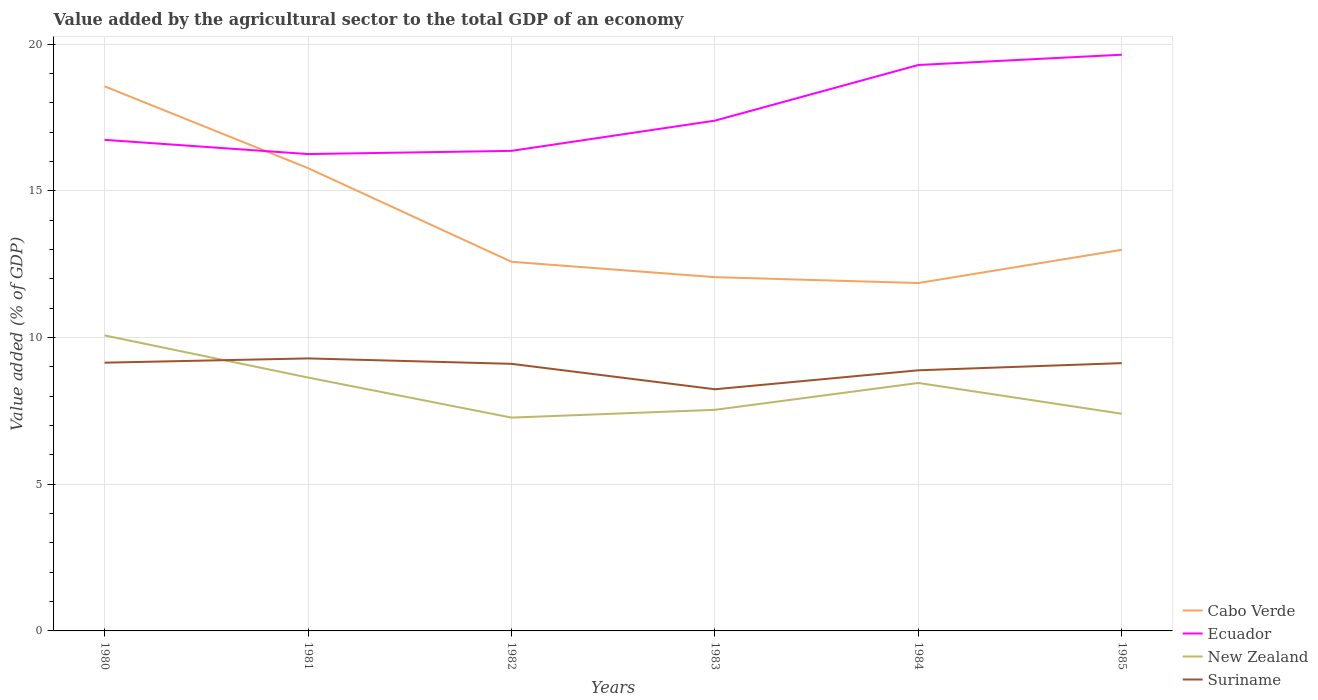Is the number of lines equal to the number of legend labels?
Offer a terse response. Yes. Across all years, what is the maximum value added by the agricultural sector to the total GDP in Cabo Verde?
Your answer should be very brief. 11.86. In which year was the value added by the agricultural sector to the total GDP in Cabo Verde maximum?
Offer a very short reply. 1984. What is the total value added by the agricultural sector to the total GDP in Cabo Verde in the graph?
Ensure brevity in your answer.  3.72. What is the difference between the highest and the second highest value added by the agricultural sector to the total GDP in New Zealand?
Offer a very short reply. 2.8. Are the values on the major ticks of Y-axis written in scientific E-notation?
Provide a short and direct response. No. How are the legend labels stacked?
Provide a succinct answer. Vertical. What is the title of the graph?
Offer a terse response. Value added by the agricultural sector to the total GDP of an economy. What is the label or title of the X-axis?
Offer a terse response. Years. What is the label or title of the Y-axis?
Your answer should be very brief. Value added (% of GDP). What is the Value added (% of GDP) in Cabo Verde in 1980?
Give a very brief answer. 18.56. What is the Value added (% of GDP) of Ecuador in 1980?
Your response must be concise. 16.74. What is the Value added (% of GDP) of New Zealand in 1980?
Make the answer very short. 10.07. What is the Value added (% of GDP) in Suriname in 1980?
Give a very brief answer. 9.14. What is the Value added (% of GDP) in Cabo Verde in 1981?
Give a very brief answer. 15.77. What is the Value added (% of GDP) of Ecuador in 1981?
Provide a succinct answer. 16.25. What is the Value added (% of GDP) of New Zealand in 1981?
Offer a terse response. 8.64. What is the Value added (% of GDP) of Suriname in 1981?
Provide a succinct answer. 9.29. What is the Value added (% of GDP) of Cabo Verde in 1982?
Offer a very short reply. 12.58. What is the Value added (% of GDP) of Ecuador in 1982?
Provide a succinct answer. 16.36. What is the Value added (% of GDP) in New Zealand in 1982?
Your answer should be compact. 7.27. What is the Value added (% of GDP) of Suriname in 1982?
Ensure brevity in your answer.  9.1. What is the Value added (% of GDP) of Cabo Verde in 1983?
Give a very brief answer. 12.06. What is the Value added (% of GDP) in Ecuador in 1983?
Give a very brief answer. 17.39. What is the Value added (% of GDP) of New Zealand in 1983?
Make the answer very short. 7.54. What is the Value added (% of GDP) of Suriname in 1983?
Your response must be concise. 8.24. What is the Value added (% of GDP) in Cabo Verde in 1984?
Your answer should be compact. 11.86. What is the Value added (% of GDP) of Ecuador in 1984?
Keep it short and to the point. 19.29. What is the Value added (% of GDP) of New Zealand in 1984?
Offer a terse response. 8.45. What is the Value added (% of GDP) of Suriname in 1984?
Offer a terse response. 8.88. What is the Value added (% of GDP) of Cabo Verde in 1985?
Make the answer very short. 12.99. What is the Value added (% of GDP) in Ecuador in 1985?
Offer a terse response. 19.64. What is the Value added (% of GDP) of New Zealand in 1985?
Your answer should be compact. 7.4. What is the Value added (% of GDP) in Suriname in 1985?
Your answer should be compact. 9.13. Across all years, what is the maximum Value added (% of GDP) in Cabo Verde?
Give a very brief answer. 18.56. Across all years, what is the maximum Value added (% of GDP) of Ecuador?
Keep it short and to the point. 19.64. Across all years, what is the maximum Value added (% of GDP) in New Zealand?
Your answer should be compact. 10.07. Across all years, what is the maximum Value added (% of GDP) of Suriname?
Provide a short and direct response. 9.29. Across all years, what is the minimum Value added (% of GDP) of Cabo Verde?
Ensure brevity in your answer.  11.86. Across all years, what is the minimum Value added (% of GDP) in Ecuador?
Offer a terse response. 16.25. Across all years, what is the minimum Value added (% of GDP) in New Zealand?
Provide a succinct answer. 7.27. Across all years, what is the minimum Value added (% of GDP) in Suriname?
Ensure brevity in your answer.  8.24. What is the total Value added (% of GDP) in Cabo Verde in the graph?
Offer a terse response. 83.82. What is the total Value added (% of GDP) in Ecuador in the graph?
Your answer should be compact. 105.67. What is the total Value added (% of GDP) in New Zealand in the graph?
Keep it short and to the point. 49.36. What is the total Value added (% of GDP) of Suriname in the graph?
Provide a succinct answer. 53.78. What is the difference between the Value added (% of GDP) of Cabo Verde in 1980 and that in 1981?
Offer a very short reply. 2.79. What is the difference between the Value added (% of GDP) of Ecuador in 1980 and that in 1981?
Offer a terse response. 0.48. What is the difference between the Value added (% of GDP) of New Zealand in 1980 and that in 1981?
Ensure brevity in your answer.  1.44. What is the difference between the Value added (% of GDP) in Suriname in 1980 and that in 1981?
Your answer should be compact. -0.14. What is the difference between the Value added (% of GDP) in Cabo Verde in 1980 and that in 1982?
Keep it short and to the point. 5.98. What is the difference between the Value added (% of GDP) of Ecuador in 1980 and that in 1982?
Provide a short and direct response. 0.38. What is the difference between the Value added (% of GDP) in New Zealand in 1980 and that in 1982?
Provide a succinct answer. 2.8. What is the difference between the Value added (% of GDP) of Suriname in 1980 and that in 1982?
Your answer should be very brief. 0.04. What is the difference between the Value added (% of GDP) of Cabo Verde in 1980 and that in 1983?
Your answer should be compact. 6.5. What is the difference between the Value added (% of GDP) of Ecuador in 1980 and that in 1983?
Offer a terse response. -0.65. What is the difference between the Value added (% of GDP) of New Zealand in 1980 and that in 1983?
Make the answer very short. 2.54. What is the difference between the Value added (% of GDP) of Suriname in 1980 and that in 1983?
Provide a short and direct response. 0.91. What is the difference between the Value added (% of GDP) of Cabo Verde in 1980 and that in 1984?
Your answer should be compact. 6.7. What is the difference between the Value added (% of GDP) of Ecuador in 1980 and that in 1984?
Offer a very short reply. -2.55. What is the difference between the Value added (% of GDP) of New Zealand in 1980 and that in 1984?
Your answer should be very brief. 1.62. What is the difference between the Value added (% of GDP) in Suriname in 1980 and that in 1984?
Make the answer very short. 0.26. What is the difference between the Value added (% of GDP) in Cabo Verde in 1980 and that in 1985?
Provide a short and direct response. 5.57. What is the difference between the Value added (% of GDP) of Ecuador in 1980 and that in 1985?
Make the answer very short. -2.9. What is the difference between the Value added (% of GDP) of New Zealand in 1980 and that in 1985?
Provide a short and direct response. 2.67. What is the difference between the Value added (% of GDP) in Suriname in 1980 and that in 1985?
Offer a very short reply. 0.02. What is the difference between the Value added (% of GDP) in Cabo Verde in 1981 and that in 1982?
Give a very brief answer. 3.19. What is the difference between the Value added (% of GDP) in Ecuador in 1981 and that in 1982?
Your answer should be very brief. -0.11. What is the difference between the Value added (% of GDP) of New Zealand in 1981 and that in 1982?
Offer a very short reply. 1.37. What is the difference between the Value added (% of GDP) of Suriname in 1981 and that in 1982?
Offer a terse response. 0.18. What is the difference between the Value added (% of GDP) of Cabo Verde in 1981 and that in 1983?
Make the answer very short. 3.72. What is the difference between the Value added (% of GDP) of Ecuador in 1981 and that in 1983?
Give a very brief answer. -1.14. What is the difference between the Value added (% of GDP) in New Zealand in 1981 and that in 1983?
Provide a succinct answer. 1.1. What is the difference between the Value added (% of GDP) of Suriname in 1981 and that in 1983?
Give a very brief answer. 1.05. What is the difference between the Value added (% of GDP) of Cabo Verde in 1981 and that in 1984?
Your answer should be compact. 3.92. What is the difference between the Value added (% of GDP) of Ecuador in 1981 and that in 1984?
Keep it short and to the point. -3.04. What is the difference between the Value added (% of GDP) in New Zealand in 1981 and that in 1984?
Provide a short and direct response. 0.18. What is the difference between the Value added (% of GDP) of Suriname in 1981 and that in 1984?
Keep it short and to the point. 0.4. What is the difference between the Value added (% of GDP) in Cabo Verde in 1981 and that in 1985?
Your answer should be compact. 2.78. What is the difference between the Value added (% of GDP) in Ecuador in 1981 and that in 1985?
Provide a short and direct response. -3.39. What is the difference between the Value added (% of GDP) in New Zealand in 1981 and that in 1985?
Your answer should be very brief. 1.23. What is the difference between the Value added (% of GDP) in Suriname in 1981 and that in 1985?
Offer a terse response. 0.16. What is the difference between the Value added (% of GDP) of Cabo Verde in 1982 and that in 1983?
Your response must be concise. 0.52. What is the difference between the Value added (% of GDP) in Ecuador in 1982 and that in 1983?
Offer a terse response. -1.03. What is the difference between the Value added (% of GDP) in New Zealand in 1982 and that in 1983?
Your answer should be compact. -0.27. What is the difference between the Value added (% of GDP) in Suriname in 1982 and that in 1983?
Make the answer very short. 0.87. What is the difference between the Value added (% of GDP) in Cabo Verde in 1982 and that in 1984?
Keep it short and to the point. 0.72. What is the difference between the Value added (% of GDP) in Ecuador in 1982 and that in 1984?
Keep it short and to the point. -2.93. What is the difference between the Value added (% of GDP) of New Zealand in 1982 and that in 1984?
Keep it short and to the point. -1.18. What is the difference between the Value added (% of GDP) in Suriname in 1982 and that in 1984?
Your answer should be compact. 0.22. What is the difference between the Value added (% of GDP) in Cabo Verde in 1982 and that in 1985?
Provide a succinct answer. -0.41. What is the difference between the Value added (% of GDP) in Ecuador in 1982 and that in 1985?
Give a very brief answer. -3.28. What is the difference between the Value added (% of GDP) in New Zealand in 1982 and that in 1985?
Provide a succinct answer. -0.13. What is the difference between the Value added (% of GDP) in Suriname in 1982 and that in 1985?
Ensure brevity in your answer.  -0.02. What is the difference between the Value added (% of GDP) in Cabo Verde in 1983 and that in 1984?
Offer a terse response. 0.2. What is the difference between the Value added (% of GDP) of Ecuador in 1983 and that in 1984?
Provide a short and direct response. -1.9. What is the difference between the Value added (% of GDP) of New Zealand in 1983 and that in 1984?
Your answer should be compact. -0.92. What is the difference between the Value added (% of GDP) in Suriname in 1983 and that in 1984?
Give a very brief answer. -0.65. What is the difference between the Value added (% of GDP) in Cabo Verde in 1983 and that in 1985?
Keep it short and to the point. -0.93. What is the difference between the Value added (% of GDP) in Ecuador in 1983 and that in 1985?
Offer a very short reply. -2.25. What is the difference between the Value added (% of GDP) in New Zealand in 1983 and that in 1985?
Offer a very short reply. 0.13. What is the difference between the Value added (% of GDP) of Suriname in 1983 and that in 1985?
Provide a succinct answer. -0.89. What is the difference between the Value added (% of GDP) in Cabo Verde in 1984 and that in 1985?
Ensure brevity in your answer.  -1.13. What is the difference between the Value added (% of GDP) in Ecuador in 1984 and that in 1985?
Give a very brief answer. -0.35. What is the difference between the Value added (% of GDP) in New Zealand in 1984 and that in 1985?
Your answer should be compact. 1.05. What is the difference between the Value added (% of GDP) in Suriname in 1984 and that in 1985?
Keep it short and to the point. -0.24. What is the difference between the Value added (% of GDP) of Cabo Verde in 1980 and the Value added (% of GDP) of Ecuador in 1981?
Keep it short and to the point. 2.31. What is the difference between the Value added (% of GDP) of Cabo Verde in 1980 and the Value added (% of GDP) of New Zealand in 1981?
Ensure brevity in your answer.  9.92. What is the difference between the Value added (% of GDP) in Cabo Verde in 1980 and the Value added (% of GDP) in Suriname in 1981?
Make the answer very short. 9.27. What is the difference between the Value added (% of GDP) in Ecuador in 1980 and the Value added (% of GDP) in New Zealand in 1981?
Your answer should be very brief. 8.1. What is the difference between the Value added (% of GDP) in Ecuador in 1980 and the Value added (% of GDP) in Suriname in 1981?
Ensure brevity in your answer.  7.45. What is the difference between the Value added (% of GDP) of New Zealand in 1980 and the Value added (% of GDP) of Suriname in 1981?
Provide a succinct answer. 0.78. What is the difference between the Value added (% of GDP) of Cabo Verde in 1980 and the Value added (% of GDP) of Ecuador in 1982?
Your answer should be compact. 2.2. What is the difference between the Value added (% of GDP) of Cabo Verde in 1980 and the Value added (% of GDP) of New Zealand in 1982?
Provide a succinct answer. 11.29. What is the difference between the Value added (% of GDP) of Cabo Verde in 1980 and the Value added (% of GDP) of Suriname in 1982?
Your answer should be very brief. 9.46. What is the difference between the Value added (% of GDP) in Ecuador in 1980 and the Value added (% of GDP) in New Zealand in 1982?
Keep it short and to the point. 9.47. What is the difference between the Value added (% of GDP) of Ecuador in 1980 and the Value added (% of GDP) of Suriname in 1982?
Offer a very short reply. 7.63. What is the difference between the Value added (% of GDP) of New Zealand in 1980 and the Value added (% of GDP) of Suriname in 1982?
Ensure brevity in your answer.  0.97. What is the difference between the Value added (% of GDP) of Cabo Verde in 1980 and the Value added (% of GDP) of Ecuador in 1983?
Give a very brief answer. 1.17. What is the difference between the Value added (% of GDP) of Cabo Verde in 1980 and the Value added (% of GDP) of New Zealand in 1983?
Your answer should be very brief. 11.02. What is the difference between the Value added (% of GDP) in Cabo Verde in 1980 and the Value added (% of GDP) in Suriname in 1983?
Offer a terse response. 10.32. What is the difference between the Value added (% of GDP) in Ecuador in 1980 and the Value added (% of GDP) in New Zealand in 1983?
Give a very brief answer. 9.2. What is the difference between the Value added (% of GDP) of Ecuador in 1980 and the Value added (% of GDP) of Suriname in 1983?
Your answer should be compact. 8.5. What is the difference between the Value added (% of GDP) in New Zealand in 1980 and the Value added (% of GDP) in Suriname in 1983?
Ensure brevity in your answer.  1.84. What is the difference between the Value added (% of GDP) of Cabo Verde in 1980 and the Value added (% of GDP) of Ecuador in 1984?
Provide a succinct answer. -0.73. What is the difference between the Value added (% of GDP) in Cabo Verde in 1980 and the Value added (% of GDP) in New Zealand in 1984?
Make the answer very short. 10.11. What is the difference between the Value added (% of GDP) in Cabo Verde in 1980 and the Value added (% of GDP) in Suriname in 1984?
Ensure brevity in your answer.  9.68. What is the difference between the Value added (% of GDP) in Ecuador in 1980 and the Value added (% of GDP) in New Zealand in 1984?
Provide a short and direct response. 8.29. What is the difference between the Value added (% of GDP) of Ecuador in 1980 and the Value added (% of GDP) of Suriname in 1984?
Provide a succinct answer. 7.85. What is the difference between the Value added (% of GDP) in New Zealand in 1980 and the Value added (% of GDP) in Suriname in 1984?
Offer a terse response. 1.19. What is the difference between the Value added (% of GDP) in Cabo Verde in 1980 and the Value added (% of GDP) in Ecuador in 1985?
Your answer should be compact. -1.08. What is the difference between the Value added (% of GDP) of Cabo Verde in 1980 and the Value added (% of GDP) of New Zealand in 1985?
Provide a succinct answer. 11.16. What is the difference between the Value added (% of GDP) in Cabo Verde in 1980 and the Value added (% of GDP) in Suriname in 1985?
Your answer should be compact. 9.43. What is the difference between the Value added (% of GDP) in Ecuador in 1980 and the Value added (% of GDP) in New Zealand in 1985?
Give a very brief answer. 9.34. What is the difference between the Value added (% of GDP) of Ecuador in 1980 and the Value added (% of GDP) of Suriname in 1985?
Your answer should be compact. 7.61. What is the difference between the Value added (% of GDP) in New Zealand in 1980 and the Value added (% of GDP) in Suriname in 1985?
Give a very brief answer. 0.94. What is the difference between the Value added (% of GDP) in Cabo Verde in 1981 and the Value added (% of GDP) in Ecuador in 1982?
Provide a short and direct response. -0.59. What is the difference between the Value added (% of GDP) of Cabo Verde in 1981 and the Value added (% of GDP) of New Zealand in 1982?
Ensure brevity in your answer.  8.5. What is the difference between the Value added (% of GDP) in Cabo Verde in 1981 and the Value added (% of GDP) in Suriname in 1982?
Provide a succinct answer. 6.67. What is the difference between the Value added (% of GDP) in Ecuador in 1981 and the Value added (% of GDP) in New Zealand in 1982?
Provide a succinct answer. 8.98. What is the difference between the Value added (% of GDP) of Ecuador in 1981 and the Value added (% of GDP) of Suriname in 1982?
Make the answer very short. 7.15. What is the difference between the Value added (% of GDP) of New Zealand in 1981 and the Value added (% of GDP) of Suriname in 1982?
Keep it short and to the point. -0.47. What is the difference between the Value added (% of GDP) of Cabo Verde in 1981 and the Value added (% of GDP) of Ecuador in 1983?
Offer a very short reply. -1.62. What is the difference between the Value added (% of GDP) of Cabo Verde in 1981 and the Value added (% of GDP) of New Zealand in 1983?
Provide a succinct answer. 8.24. What is the difference between the Value added (% of GDP) of Cabo Verde in 1981 and the Value added (% of GDP) of Suriname in 1983?
Keep it short and to the point. 7.54. What is the difference between the Value added (% of GDP) of Ecuador in 1981 and the Value added (% of GDP) of New Zealand in 1983?
Ensure brevity in your answer.  8.72. What is the difference between the Value added (% of GDP) in Ecuador in 1981 and the Value added (% of GDP) in Suriname in 1983?
Keep it short and to the point. 8.02. What is the difference between the Value added (% of GDP) of New Zealand in 1981 and the Value added (% of GDP) of Suriname in 1983?
Provide a short and direct response. 0.4. What is the difference between the Value added (% of GDP) in Cabo Verde in 1981 and the Value added (% of GDP) in Ecuador in 1984?
Make the answer very short. -3.51. What is the difference between the Value added (% of GDP) of Cabo Verde in 1981 and the Value added (% of GDP) of New Zealand in 1984?
Your answer should be very brief. 7.32. What is the difference between the Value added (% of GDP) in Cabo Verde in 1981 and the Value added (% of GDP) in Suriname in 1984?
Your answer should be compact. 6.89. What is the difference between the Value added (% of GDP) of Ecuador in 1981 and the Value added (% of GDP) of New Zealand in 1984?
Offer a very short reply. 7.8. What is the difference between the Value added (% of GDP) in Ecuador in 1981 and the Value added (% of GDP) in Suriname in 1984?
Make the answer very short. 7.37. What is the difference between the Value added (% of GDP) in New Zealand in 1981 and the Value added (% of GDP) in Suriname in 1984?
Offer a terse response. -0.25. What is the difference between the Value added (% of GDP) in Cabo Verde in 1981 and the Value added (% of GDP) in Ecuador in 1985?
Keep it short and to the point. -3.87. What is the difference between the Value added (% of GDP) in Cabo Verde in 1981 and the Value added (% of GDP) in New Zealand in 1985?
Offer a very short reply. 8.37. What is the difference between the Value added (% of GDP) in Cabo Verde in 1981 and the Value added (% of GDP) in Suriname in 1985?
Ensure brevity in your answer.  6.65. What is the difference between the Value added (% of GDP) in Ecuador in 1981 and the Value added (% of GDP) in New Zealand in 1985?
Offer a terse response. 8.85. What is the difference between the Value added (% of GDP) in Ecuador in 1981 and the Value added (% of GDP) in Suriname in 1985?
Keep it short and to the point. 7.13. What is the difference between the Value added (% of GDP) of New Zealand in 1981 and the Value added (% of GDP) of Suriname in 1985?
Your answer should be compact. -0.49. What is the difference between the Value added (% of GDP) of Cabo Verde in 1982 and the Value added (% of GDP) of Ecuador in 1983?
Keep it short and to the point. -4.81. What is the difference between the Value added (% of GDP) in Cabo Verde in 1982 and the Value added (% of GDP) in New Zealand in 1983?
Keep it short and to the point. 5.04. What is the difference between the Value added (% of GDP) of Cabo Verde in 1982 and the Value added (% of GDP) of Suriname in 1983?
Ensure brevity in your answer.  4.34. What is the difference between the Value added (% of GDP) in Ecuador in 1982 and the Value added (% of GDP) in New Zealand in 1983?
Give a very brief answer. 8.83. What is the difference between the Value added (% of GDP) in Ecuador in 1982 and the Value added (% of GDP) in Suriname in 1983?
Offer a very short reply. 8.12. What is the difference between the Value added (% of GDP) in New Zealand in 1982 and the Value added (% of GDP) in Suriname in 1983?
Give a very brief answer. -0.97. What is the difference between the Value added (% of GDP) in Cabo Verde in 1982 and the Value added (% of GDP) in Ecuador in 1984?
Give a very brief answer. -6.71. What is the difference between the Value added (% of GDP) of Cabo Verde in 1982 and the Value added (% of GDP) of New Zealand in 1984?
Your answer should be very brief. 4.13. What is the difference between the Value added (% of GDP) of Cabo Verde in 1982 and the Value added (% of GDP) of Suriname in 1984?
Your answer should be compact. 3.7. What is the difference between the Value added (% of GDP) of Ecuador in 1982 and the Value added (% of GDP) of New Zealand in 1984?
Ensure brevity in your answer.  7.91. What is the difference between the Value added (% of GDP) in Ecuador in 1982 and the Value added (% of GDP) in Suriname in 1984?
Your answer should be very brief. 7.48. What is the difference between the Value added (% of GDP) in New Zealand in 1982 and the Value added (% of GDP) in Suriname in 1984?
Your response must be concise. -1.61. What is the difference between the Value added (% of GDP) in Cabo Verde in 1982 and the Value added (% of GDP) in Ecuador in 1985?
Your answer should be very brief. -7.06. What is the difference between the Value added (% of GDP) of Cabo Verde in 1982 and the Value added (% of GDP) of New Zealand in 1985?
Ensure brevity in your answer.  5.18. What is the difference between the Value added (% of GDP) of Cabo Verde in 1982 and the Value added (% of GDP) of Suriname in 1985?
Offer a very short reply. 3.45. What is the difference between the Value added (% of GDP) in Ecuador in 1982 and the Value added (% of GDP) in New Zealand in 1985?
Provide a succinct answer. 8.96. What is the difference between the Value added (% of GDP) in Ecuador in 1982 and the Value added (% of GDP) in Suriname in 1985?
Your answer should be compact. 7.23. What is the difference between the Value added (% of GDP) of New Zealand in 1982 and the Value added (% of GDP) of Suriname in 1985?
Provide a succinct answer. -1.86. What is the difference between the Value added (% of GDP) of Cabo Verde in 1983 and the Value added (% of GDP) of Ecuador in 1984?
Provide a succinct answer. -7.23. What is the difference between the Value added (% of GDP) of Cabo Verde in 1983 and the Value added (% of GDP) of New Zealand in 1984?
Keep it short and to the point. 3.61. What is the difference between the Value added (% of GDP) in Cabo Verde in 1983 and the Value added (% of GDP) in Suriname in 1984?
Provide a short and direct response. 3.17. What is the difference between the Value added (% of GDP) in Ecuador in 1983 and the Value added (% of GDP) in New Zealand in 1984?
Give a very brief answer. 8.94. What is the difference between the Value added (% of GDP) in Ecuador in 1983 and the Value added (% of GDP) in Suriname in 1984?
Provide a succinct answer. 8.51. What is the difference between the Value added (% of GDP) in New Zealand in 1983 and the Value added (% of GDP) in Suriname in 1984?
Offer a terse response. -1.35. What is the difference between the Value added (% of GDP) in Cabo Verde in 1983 and the Value added (% of GDP) in Ecuador in 1985?
Provide a succinct answer. -7.58. What is the difference between the Value added (% of GDP) in Cabo Verde in 1983 and the Value added (% of GDP) in New Zealand in 1985?
Your answer should be very brief. 4.66. What is the difference between the Value added (% of GDP) of Cabo Verde in 1983 and the Value added (% of GDP) of Suriname in 1985?
Offer a very short reply. 2.93. What is the difference between the Value added (% of GDP) in Ecuador in 1983 and the Value added (% of GDP) in New Zealand in 1985?
Your answer should be compact. 9.99. What is the difference between the Value added (% of GDP) in Ecuador in 1983 and the Value added (% of GDP) in Suriname in 1985?
Offer a very short reply. 8.26. What is the difference between the Value added (% of GDP) of New Zealand in 1983 and the Value added (% of GDP) of Suriname in 1985?
Offer a very short reply. -1.59. What is the difference between the Value added (% of GDP) in Cabo Verde in 1984 and the Value added (% of GDP) in Ecuador in 1985?
Offer a terse response. -7.78. What is the difference between the Value added (% of GDP) in Cabo Verde in 1984 and the Value added (% of GDP) in New Zealand in 1985?
Your answer should be compact. 4.46. What is the difference between the Value added (% of GDP) of Cabo Verde in 1984 and the Value added (% of GDP) of Suriname in 1985?
Make the answer very short. 2.73. What is the difference between the Value added (% of GDP) of Ecuador in 1984 and the Value added (% of GDP) of New Zealand in 1985?
Your answer should be very brief. 11.89. What is the difference between the Value added (% of GDP) in Ecuador in 1984 and the Value added (% of GDP) in Suriname in 1985?
Your response must be concise. 10.16. What is the difference between the Value added (% of GDP) of New Zealand in 1984 and the Value added (% of GDP) of Suriname in 1985?
Offer a terse response. -0.68. What is the average Value added (% of GDP) in Cabo Verde per year?
Offer a very short reply. 13.97. What is the average Value added (% of GDP) of Ecuador per year?
Provide a short and direct response. 17.61. What is the average Value added (% of GDP) of New Zealand per year?
Provide a succinct answer. 8.23. What is the average Value added (% of GDP) of Suriname per year?
Offer a very short reply. 8.96. In the year 1980, what is the difference between the Value added (% of GDP) in Cabo Verde and Value added (% of GDP) in Ecuador?
Make the answer very short. 1.82. In the year 1980, what is the difference between the Value added (% of GDP) of Cabo Verde and Value added (% of GDP) of New Zealand?
Make the answer very short. 8.49. In the year 1980, what is the difference between the Value added (% of GDP) of Cabo Verde and Value added (% of GDP) of Suriname?
Ensure brevity in your answer.  9.42. In the year 1980, what is the difference between the Value added (% of GDP) of Ecuador and Value added (% of GDP) of New Zealand?
Ensure brevity in your answer.  6.67. In the year 1980, what is the difference between the Value added (% of GDP) of Ecuador and Value added (% of GDP) of Suriname?
Give a very brief answer. 7.59. In the year 1980, what is the difference between the Value added (% of GDP) in New Zealand and Value added (% of GDP) in Suriname?
Keep it short and to the point. 0.93. In the year 1981, what is the difference between the Value added (% of GDP) in Cabo Verde and Value added (% of GDP) in Ecuador?
Your answer should be very brief. -0.48. In the year 1981, what is the difference between the Value added (% of GDP) in Cabo Verde and Value added (% of GDP) in New Zealand?
Provide a succinct answer. 7.14. In the year 1981, what is the difference between the Value added (% of GDP) of Cabo Verde and Value added (% of GDP) of Suriname?
Give a very brief answer. 6.49. In the year 1981, what is the difference between the Value added (% of GDP) in Ecuador and Value added (% of GDP) in New Zealand?
Ensure brevity in your answer.  7.62. In the year 1981, what is the difference between the Value added (% of GDP) in Ecuador and Value added (% of GDP) in Suriname?
Your answer should be very brief. 6.96. In the year 1981, what is the difference between the Value added (% of GDP) in New Zealand and Value added (% of GDP) in Suriname?
Make the answer very short. -0.65. In the year 1982, what is the difference between the Value added (% of GDP) of Cabo Verde and Value added (% of GDP) of Ecuador?
Your response must be concise. -3.78. In the year 1982, what is the difference between the Value added (% of GDP) of Cabo Verde and Value added (% of GDP) of New Zealand?
Give a very brief answer. 5.31. In the year 1982, what is the difference between the Value added (% of GDP) of Cabo Verde and Value added (% of GDP) of Suriname?
Provide a short and direct response. 3.48. In the year 1982, what is the difference between the Value added (% of GDP) of Ecuador and Value added (% of GDP) of New Zealand?
Keep it short and to the point. 9.09. In the year 1982, what is the difference between the Value added (% of GDP) of Ecuador and Value added (% of GDP) of Suriname?
Your answer should be compact. 7.26. In the year 1982, what is the difference between the Value added (% of GDP) in New Zealand and Value added (% of GDP) in Suriname?
Provide a succinct answer. -1.83. In the year 1983, what is the difference between the Value added (% of GDP) in Cabo Verde and Value added (% of GDP) in Ecuador?
Provide a short and direct response. -5.33. In the year 1983, what is the difference between the Value added (% of GDP) of Cabo Verde and Value added (% of GDP) of New Zealand?
Offer a terse response. 4.52. In the year 1983, what is the difference between the Value added (% of GDP) in Cabo Verde and Value added (% of GDP) in Suriname?
Provide a succinct answer. 3.82. In the year 1983, what is the difference between the Value added (% of GDP) of Ecuador and Value added (% of GDP) of New Zealand?
Offer a very short reply. 9.86. In the year 1983, what is the difference between the Value added (% of GDP) in Ecuador and Value added (% of GDP) in Suriname?
Make the answer very short. 9.15. In the year 1983, what is the difference between the Value added (% of GDP) in New Zealand and Value added (% of GDP) in Suriname?
Provide a succinct answer. -0.7. In the year 1984, what is the difference between the Value added (% of GDP) of Cabo Verde and Value added (% of GDP) of Ecuador?
Provide a succinct answer. -7.43. In the year 1984, what is the difference between the Value added (% of GDP) of Cabo Verde and Value added (% of GDP) of New Zealand?
Your answer should be very brief. 3.41. In the year 1984, what is the difference between the Value added (% of GDP) of Cabo Verde and Value added (% of GDP) of Suriname?
Provide a short and direct response. 2.97. In the year 1984, what is the difference between the Value added (% of GDP) of Ecuador and Value added (% of GDP) of New Zealand?
Offer a very short reply. 10.84. In the year 1984, what is the difference between the Value added (% of GDP) of Ecuador and Value added (% of GDP) of Suriname?
Give a very brief answer. 10.4. In the year 1984, what is the difference between the Value added (% of GDP) of New Zealand and Value added (% of GDP) of Suriname?
Offer a very short reply. -0.43. In the year 1985, what is the difference between the Value added (% of GDP) of Cabo Verde and Value added (% of GDP) of Ecuador?
Your answer should be compact. -6.65. In the year 1985, what is the difference between the Value added (% of GDP) in Cabo Verde and Value added (% of GDP) in New Zealand?
Your answer should be very brief. 5.59. In the year 1985, what is the difference between the Value added (% of GDP) of Cabo Verde and Value added (% of GDP) of Suriname?
Give a very brief answer. 3.86. In the year 1985, what is the difference between the Value added (% of GDP) of Ecuador and Value added (% of GDP) of New Zealand?
Offer a terse response. 12.24. In the year 1985, what is the difference between the Value added (% of GDP) in Ecuador and Value added (% of GDP) in Suriname?
Ensure brevity in your answer.  10.51. In the year 1985, what is the difference between the Value added (% of GDP) of New Zealand and Value added (% of GDP) of Suriname?
Keep it short and to the point. -1.73. What is the ratio of the Value added (% of GDP) in Cabo Verde in 1980 to that in 1981?
Provide a short and direct response. 1.18. What is the ratio of the Value added (% of GDP) of Ecuador in 1980 to that in 1981?
Your answer should be compact. 1.03. What is the ratio of the Value added (% of GDP) in New Zealand in 1980 to that in 1981?
Your answer should be compact. 1.17. What is the ratio of the Value added (% of GDP) of Suriname in 1980 to that in 1981?
Ensure brevity in your answer.  0.98. What is the ratio of the Value added (% of GDP) of Cabo Verde in 1980 to that in 1982?
Keep it short and to the point. 1.48. What is the ratio of the Value added (% of GDP) of New Zealand in 1980 to that in 1982?
Your response must be concise. 1.39. What is the ratio of the Value added (% of GDP) in Suriname in 1980 to that in 1982?
Your response must be concise. 1. What is the ratio of the Value added (% of GDP) of Cabo Verde in 1980 to that in 1983?
Your response must be concise. 1.54. What is the ratio of the Value added (% of GDP) in Ecuador in 1980 to that in 1983?
Offer a very short reply. 0.96. What is the ratio of the Value added (% of GDP) in New Zealand in 1980 to that in 1983?
Offer a very short reply. 1.34. What is the ratio of the Value added (% of GDP) in Suriname in 1980 to that in 1983?
Offer a very short reply. 1.11. What is the ratio of the Value added (% of GDP) in Cabo Verde in 1980 to that in 1984?
Offer a terse response. 1.57. What is the ratio of the Value added (% of GDP) of Ecuador in 1980 to that in 1984?
Offer a terse response. 0.87. What is the ratio of the Value added (% of GDP) of New Zealand in 1980 to that in 1984?
Provide a succinct answer. 1.19. What is the ratio of the Value added (% of GDP) in Suriname in 1980 to that in 1984?
Your answer should be very brief. 1.03. What is the ratio of the Value added (% of GDP) of Cabo Verde in 1980 to that in 1985?
Offer a very short reply. 1.43. What is the ratio of the Value added (% of GDP) in Ecuador in 1980 to that in 1985?
Your response must be concise. 0.85. What is the ratio of the Value added (% of GDP) of New Zealand in 1980 to that in 1985?
Offer a terse response. 1.36. What is the ratio of the Value added (% of GDP) of Cabo Verde in 1981 to that in 1982?
Your answer should be compact. 1.25. What is the ratio of the Value added (% of GDP) in Ecuador in 1981 to that in 1982?
Give a very brief answer. 0.99. What is the ratio of the Value added (% of GDP) of New Zealand in 1981 to that in 1982?
Offer a terse response. 1.19. What is the ratio of the Value added (% of GDP) in Suriname in 1981 to that in 1982?
Provide a succinct answer. 1.02. What is the ratio of the Value added (% of GDP) of Cabo Verde in 1981 to that in 1983?
Make the answer very short. 1.31. What is the ratio of the Value added (% of GDP) of Ecuador in 1981 to that in 1983?
Ensure brevity in your answer.  0.93. What is the ratio of the Value added (% of GDP) in New Zealand in 1981 to that in 1983?
Keep it short and to the point. 1.15. What is the ratio of the Value added (% of GDP) of Suriname in 1981 to that in 1983?
Ensure brevity in your answer.  1.13. What is the ratio of the Value added (% of GDP) of Cabo Verde in 1981 to that in 1984?
Ensure brevity in your answer.  1.33. What is the ratio of the Value added (% of GDP) of Ecuador in 1981 to that in 1984?
Make the answer very short. 0.84. What is the ratio of the Value added (% of GDP) in New Zealand in 1981 to that in 1984?
Provide a short and direct response. 1.02. What is the ratio of the Value added (% of GDP) in Suriname in 1981 to that in 1984?
Provide a succinct answer. 1.05. What is the ratio of the Value added (% of GDP) in Cabo Verde in 1981 to that in 1985?
Your answer should be compact. 1.21. What is the ratio of the Value added (% of GDP) in Ecuador in 1981 to that in 1985?
Your answer should be compact. 0.83. What is the ratio of the Value added (% of GDP) of New Zealand in 1981 to that in 1985?
Your answer should be compact. 1.17. What is the ratio of the Value added (% of GDP) in Suriname in 1981 to that in 1985?
Give a very brief answer. 1.02. What is the ratio of the Value added (% of GDP) in Cabo Verde in 1982 to that in 1983?
Your answer should be compact. 1.04. What is the ratio of the Value added (% of GDP) of Ecuador in 1982 to that in 1983?
Ensure brevity in your answer.  0.94. What is the ratio of the Value added (% of GDP) of New Zealand in 1982 to that in 1983?
Your answer should be compact. 0.96. What is the ratio of the Value added (% of GDP) in Suriname in 1982 to that in 1983?
Ensure brevity in your answer.  1.11. What is the ratio of the Value added (% of GDP) of Cabo Verde in 1982 to that in 1984?
Provide a succinct answer. 1.06. What is the ratio of the Value added (% of GDP) in Ecuador in 1982 to that in 1984?
Offer a very short reply. 0.85. What is the ratio of the Value added (% of GDP) of New Zealand in 1982 to that in 1984?
Provide a succinct answer. 0.86. What is the ratio of the Value added (% of GDP) in Suriname in 1982 to that in 1984?
Keep it short and to the point. 1.02. What is the ratio of the Value added (% of GDP) of Cabo Verde in 1982 to that in 1985?
Give a very brief answer. 0.97. What is the ratio of the Value added (% of GDP) in Ecuador in 1982 to that in 1985?
Your response must be concise. 0.83. What is the ratio of the Value added (% of GDP) in New Zealand in 1982 to that in 1985?
Keep it short and to the point. 0.98. What is the ratio of the Value added (% of GDP) in Suriname in 1982 to that in 1985?
Offer a very short reply. 1. What is the ratio of the Value added (% of GDP) of Cabo Verde in 1983 to that in 1984?
Your answer should be compact. 1.02. What is the ratio of the Value added (% of GDP) in Ecuador in 1983 to that in 1984?
Your answer should be very brief. 0.9. What is the ratio of the Value added (% of GDP) of New Zealand in 1983 to that in 1984?
Ensure brevity in your answer.  0.89. What is the ratio of the Value added (% of GDP) of Suriname in 1983 to that in 1984?
Your response must be concise. 0.93. What is the ratio of the Value added (% of GDP) in Cabo Verde in 1983 to that in 1985?
Your response must be concise. 0.93. What is the ratio of the Value added (% of GDP) of Ecuador in 1983 to that in 1985?
Your answer should be very brief. 0.89. What is the ratio of the Value added (% of GDP) in New Zealand in 1983 to that in 1985?
Keep it short and to the point. 1.02. What is the ratio of the Value added (% of GDP) of Suriname in 1983 to that in 1985?
Ensure brevity in your answer.  0.9. What is the ratio of the Value added (% of GDP) of Cabo Verde in 1984 to that in 1985?
Offer a terse response. 0.91. What is the ratio of the Value added (% of GDP) of Ecuador in 1984 to that in 1985?
Keep it short and to the point. 0.98. What is the ratio of the Value added (% of GDP) in New Zealand in 1984 to that in 1985?
Offer a terse response. 1.14. What is the ratio of the Value added (% of GDP) of Suriname in 1984 to that in 1985?
Offer a very short reply. 0.97. What is the difference between the highest and the second highest Value added (% of GDP) of Cabo Verde?
Your answer should be very brief. 2.79. What is the difference between the highest and the second highest Value added (% of GDP) of Ecuador?
Provide a short and direct response. 0.35. What is the difference between the highest and the second highest Value added (% of GDP) of New Zealand?
Make the answer very short. 1.44. What is the difference between the highest and the second highest Value added (% of GDP) of Suriname?
Make the answer very short. 0.14. What is the difference between the highest and the lowest Value added (% of GDP) of Cabo Verde?
Make the answer very short. 6.7. What is the difference between the highest and the lowest Value added (% of GDP) in Ecuador?
Your answer should be very brief. 3.39. What is the difference between the highest and the lowest Value added (% of GDP) of New Zealand?
Your answer should be very brief. 2.8. What is the difference between the highest and the lowest Value added (% of GDP) of Suriname?
Your response must be concise. 1.05. 